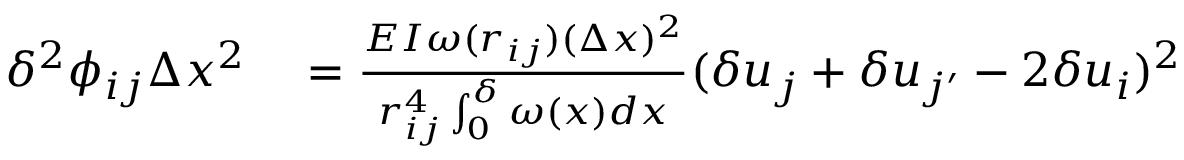<formula> <loc_0><loc_0><loc_500><loc_500>\begin{array} { r l } { \delta ^ { 2 } \phi _ { i j } \Delta x ^ { 2 } } & = \frac { E I \omega ( r _ { i j } ) ( \Delta x ) ^ { 2 } } { r _ { i j } ^ { 4 } \int _ { 0 } ^ { \delta } \omega ( x ) d x } ( \delta u _ { j } + \delta u _ { j ^ { \prime } } - 2 \delta u _ { i } ) ^ { 2 } } \end{array}</formula> 